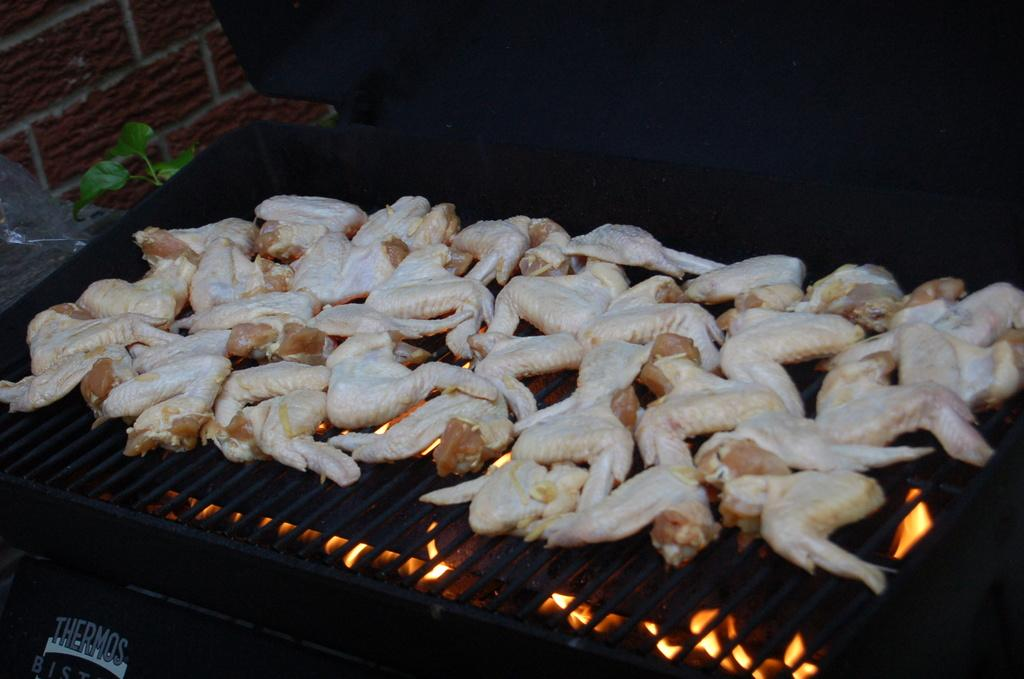What is the main object in the image? There is a barbecue grill in the image. What is happening to the food items in the image? The food items are on the barbecue grill. Can you describe the girl in the image? There is a girl in the image. What is located on the left side of the girl? There is a plant and a wall on the left side of the girl. What type of glass is being used to recite a verse in the image? There is no glass or verse present in the image. Where is the basin located in the image? There is no basin present in the image. 